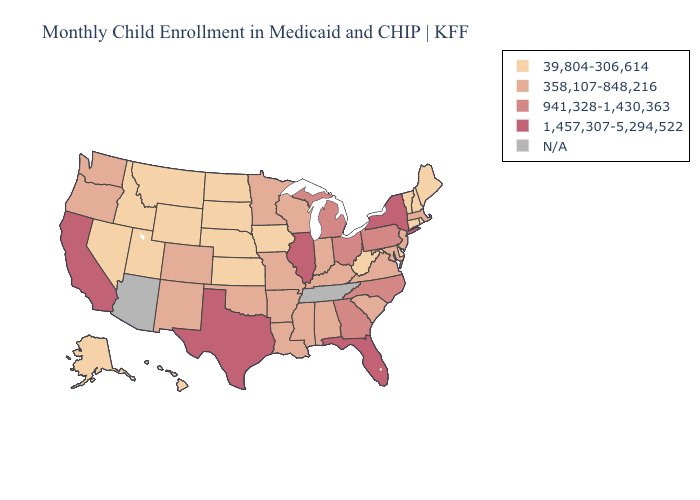Which states have the lowest value in the USA?
Keep it brief. Alaska, Connecticut, Delaware, Hawaii, Idaho, Iowa, Kansas, Maine, Montana, Nebraska, Nevada, New Hampshire, North Dakota, Rhode Island, South Dakota, Utah, Vermont, West Virginia, Wyoming. Does New York have the highest value in the Northeast?
Concise answer only. Yes. Does Connecticut have the highest value in the Northeast?
Answer briefly. No. Name the states that have a value in the range 1,457,307-5,294,522?
Short answer required. California, Florida, Illinois, New York, Texas. What is the value of Louisiana?
Answer briefly. 358,107-848,216. What is the lowest value in states that border Minnesota?
Answer briefly. 39,804-306,614. What is the value of Ohio?
Answer briefly. 941,328-1,430,363. What is the highest value in states that border Colorado?
Answer briefly. 358,107-848,216. Among the states that border South Dakota , which have the lowest value?
Quick response, please. Iowa, Montana, Nebraska, North Dakota, Wyoming. What is the value of Illinois?
Short answer required. 1,457,307-5,294,522. Does the map have missing data?
Quick response, please. Yes. What is the value of Wisconsin?
Quick response, please. 358,107-848,216. Does Illinois have the lowest value in the MidWest?
Be succinct. No. 